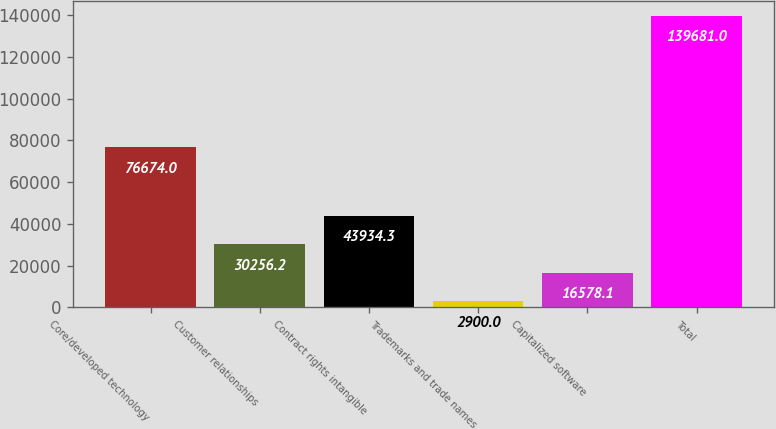Convert chart to OTSL. <chart><loc_0><loc_0><loc_500><loc_500><bar_chart><fcel>Core/developed technology<fcel>Customer relationships<fcel>Contract rights intangible<fcel>Trademarks and trade names<fcel>Capitalized software<fcel>Total<nl><fcel>76674<fcel>30256.2<fcel>43934.3<fcel>2900<fcel>16578.1<fcel>139681<nl></chart> 